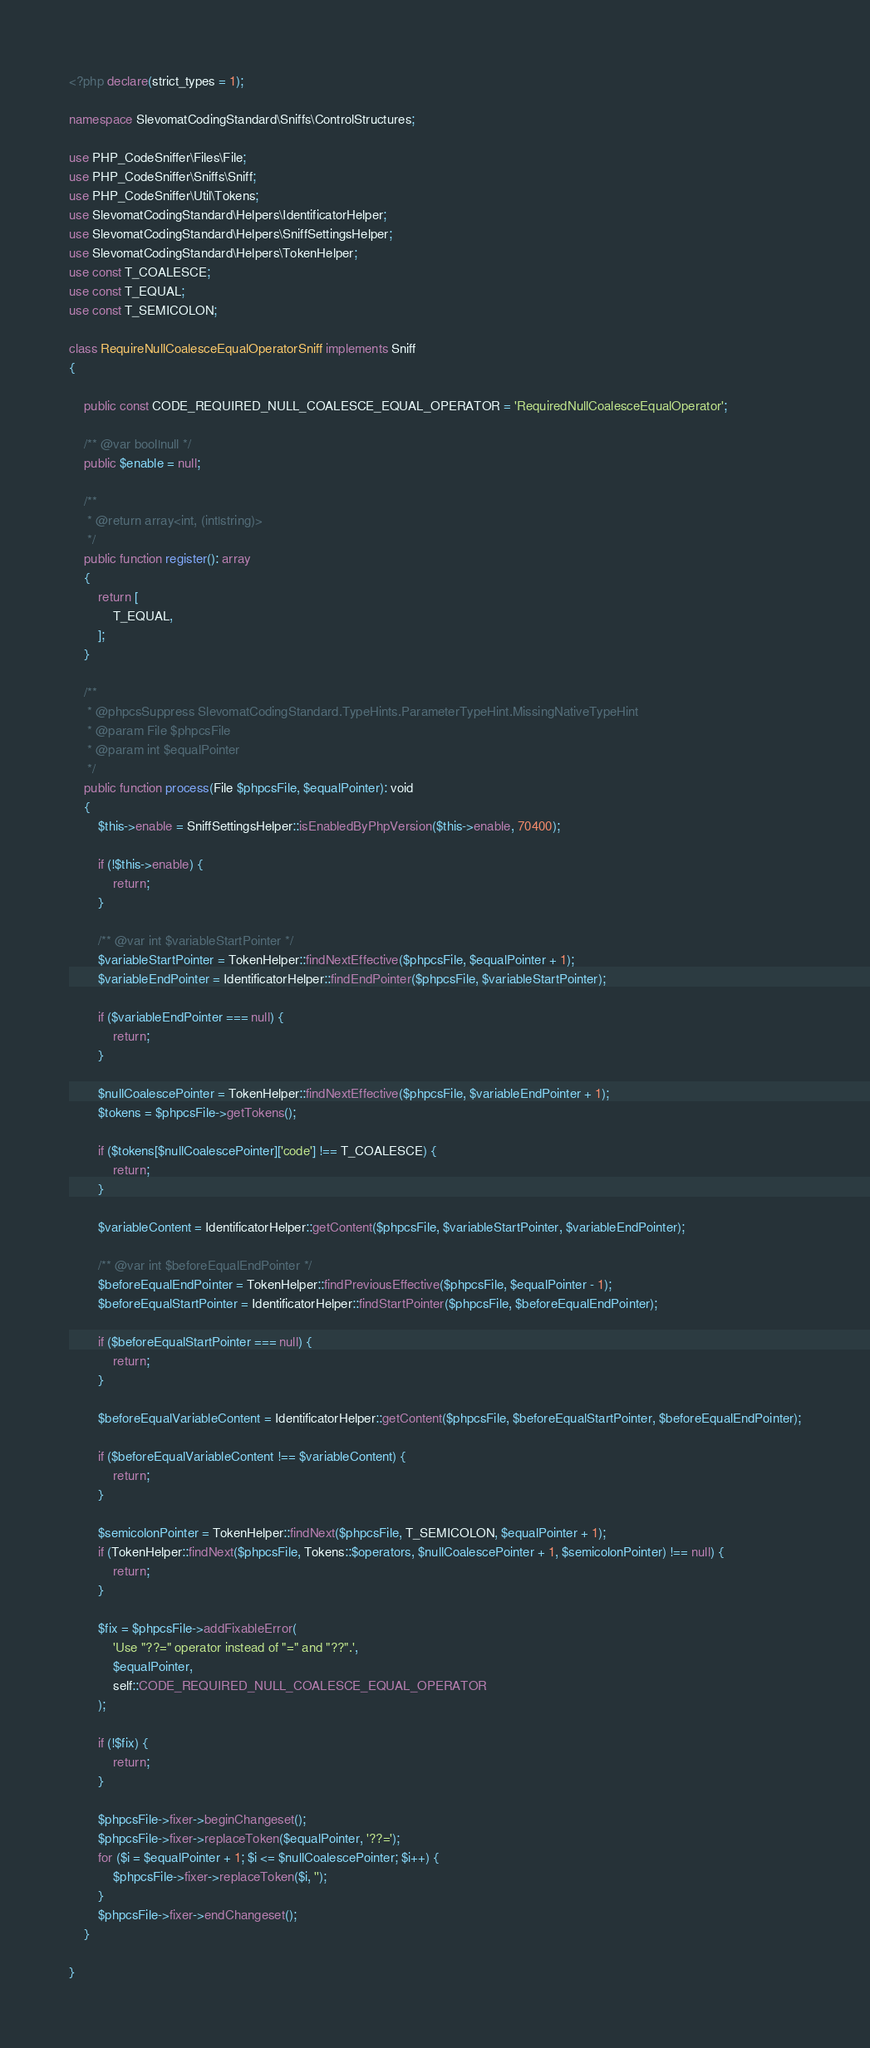Convert code to text. <code><loc_0><loc_0><loc_500><loc_500><_PHP_><?php declare(strict_types = 1);

namespace SlevomatCodingStandard\Sniffs\ControlStructures;

use PHP_CodeSniffer\Files\File;
use PHP_CodeSniffer\Sniffs\Sniff;
use PHP_CodeSniffer\Util\Tokens;
use SlevomatCodingStandard\Helpers\IdentificatorHelper;
use SlevomatCodingStandard\Helpers\SniffSettingsHelper;
use SlevomatCodingStandard\Helpers\TokenHelper;
use const T_COALESCE;
use const T_EQUAL;
use const T_SEMICOLON;

class RequireNullCoalesceEqualOperatorSniff implements Sniff
{

	public const CODE_REQUIRED_NULL_COALESCE_EQUAL_OPERATOR = 'RequiredNullCoalesceEqualOperator';

	/** @var bool|null */
	public $enable = null;

	/**
	 * @return array<int, (int|string)>
	 */
	public function register(): array
	{
		return [
			T_EQUAL,
		];
	}

	/**
	 * @phpcsSuppress SlevomatCodingStandard.TypeHints.ParameterTypeHint.MissingNativeTypeHint
	 * @param File $phpcsFile
	 * @param int $equalPointer
	 */
	public function process(File $phpcsFile, $equalPointer): void
	{
		$this->enable = SniffSettingsHelper::isEnabledByPhpVersion($this->enable, 70400);

		if (!$this->enable) {
			return;
		}

		/** @var int $variableStartPointer */
		$variableStartPointer = TokenHelper::findNextEffective($phpcsFile, $equalPointer + 1);
		$variableEndPointer = IdentificatorHelper::findEndPointer($phpcsFile, $variableStartPointer);

		if ($variableEndPointer === null) {
			return;
		}

		$nullCoalescePointer = TokenHelper::findNextEffective($phpcsFile, $variableEndPointer + 1);
		$tokens = $phpcsFile->getTokens();

		if ($tokens[$nullCoalescePointer]['code'] !== T_COALESCE) {
			return;
		}

		$variableContent = IdentificatorHelper::getContent($phpcsFile, $variableStartPointer, $variableEndPointer);

		/** @var int $beforeEqualEndPointer */
		$beforeEqualEndPointer = TokenHelper::findPreviousEffective($phpcsFile, $equalPointer - 1);
		$beforeEqualStartPointer = IdentificatorHelper::findStartPointer($phpcsFile, $beforeEqualEndPointer);

		if ($beforeEqualStartPointer === null) {
			return;
		}

		$beforeEqualVariableContent = IdentificatorHelper::getContent($phpcsFile, $beforeEqualStartPointer, $beforeEqualEndPointer);

		if ($beforeEqualVariableContent !== $variableContent) {
			return;
		}

		$semicolonPointer = TokenHelper::findNext($phpcsFile, T_SEMICOLON, $equalPointer + 1);
		if (TokenHelper::findNext($phpcsFile, Tokens::$operators, $nullCoalescePointer + 1, $semicolonPointer) !== null) {
			return;
		}

		$fix = $phpcsFile->addFixableError(
			'Use "??=" operator instead of "=" and "??".',
			$equalPointer,
			self::CODE_REQUIRED_NULL_COALESCE_EQUAL_OPERATOR
		);

		if (!$fix) {
			return;
		}

		$phpcsFile->fixer->beginChangeset();
		$phpcsFile->fixer->replaceToken($equalPointer, '??=');
		for ($i = $equalPointer + 1; $i <= $nullCoalescePointer; $i++) {
			$phpcsFile->fixer->replaceToken($i, '');
		}
		$phpcsFile->fixer->endChangeset();
	}

}
</code> 